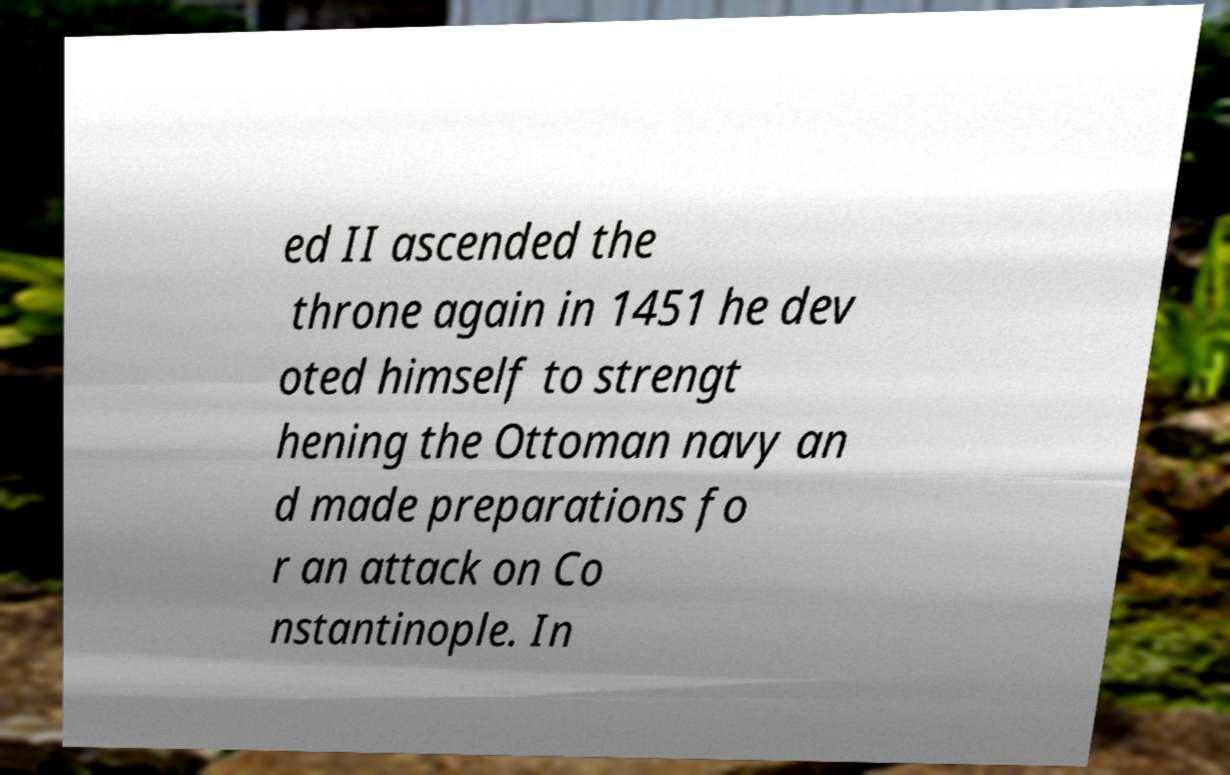Can you read and provide the text displayed in the image?This photo seems to have some interesting text. Can you extract and type it out for me? ed II ascended the throne again in 1451 he dev oted himself to strengt hening the Ottoman navy an d made preparations fo r an attack on Co nstantinople. In 